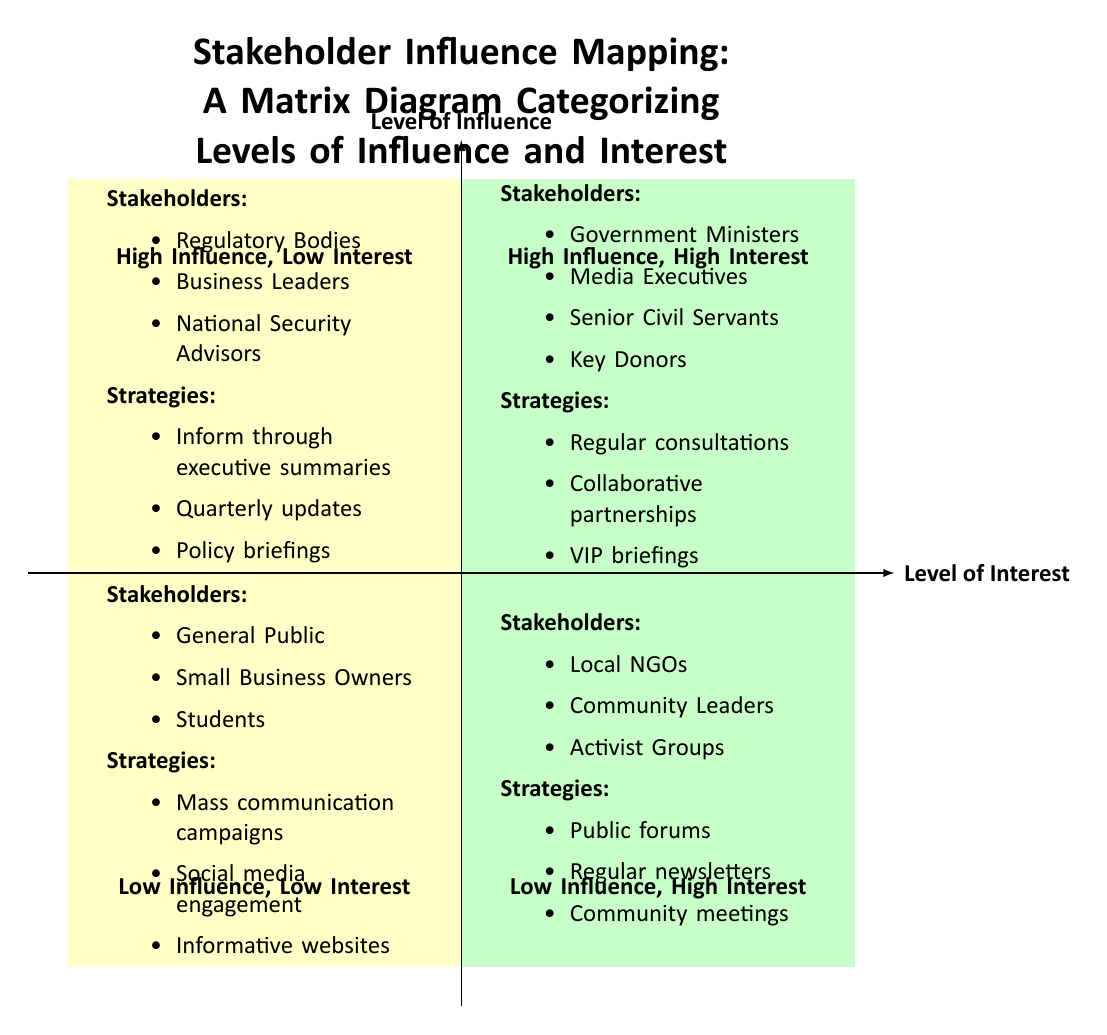What stakeholders are categorized in the "High Influence, High Interest" quadrant? This quadrant lists stakeholders who have both a high level of influence and a high level of interest. According to the diagram, these stakeholders include Government Ministers, Media Executives, Senior Civil Servants, and Key Donors.
Answer: Government Ministers, Media Executives, Senior Civil Servants, Key Donors What strategies are suggested for stakeholders in the "Low Influence, Low Interest" quadrant? In the "Low Influence, Low Interest" quadrant, the strategies suggested for stakeholders include Mass communication campaigns, Social media engagement, and Informative websites.
Answer: Mass communication campaigns, Social media engagement, Informative websites How many quadrants are represented in the diagram? The diagram is divided into four distinct quadrants: High Influence, High Interest; High Influence, Low Interest; Low Influence, High Interest; and Low Influence, Low Interest. Therefore, the answer is four.
Answer: four Which quadrant contains Local NGOs as stakeholders? Local NGOs are placed in the "Low Influence, High Interest" quadrant. This quadrant is characterized by stakeholders who are interested but do not have significant influence.
Answer: Low Influence, High Interest What is the recommended action for stakeholders classified in the "High Influence, Low Interest" quadrant? Stakeholders in this quadrant should be informed through executive summaries, receive quarterly updates, and participate in policy briefings. These strategies aim to keep them informed without overwhelming them.
Answer: Inform through executive summaries Which stakeholder group is indicated for the "High Influence, High Interest" category? The "High Influence, High Interest" category lists stakeholders that include key decision-makers, such as Government Ministers and Media Executives. This reflects both their talking power and interest in the organization's outcomes.
Answer: Government Ministers, Media Executives Which two quadrants suggest community engagement strategies? The quadrants "Low Influence, High Interest" and "Low Influence, Low Interest" suggest strategies focused on community engagement. The first one promotes public forums and regular newsletters, while the second suggests mass communication campaigns.
Answer: Low Influence, High Interest and Low Influence, Low Interest What is the primary focus of stakeholders in the "High Influence, Low Interest" quadrant? The primary focus for stakeholders in this quadrant is to ensure they are kept informed and updated efficiently, using strategies like executive summaries and quarterly updates to maintain minimal engagement without neglecting their status.
Answer: To keep them informed and updated 